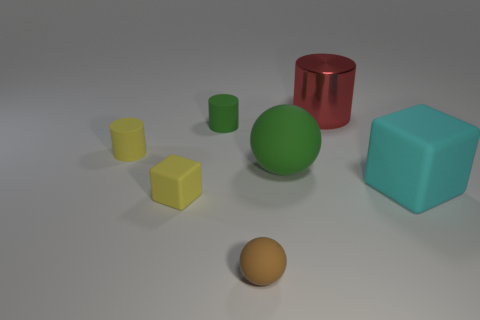Add 1 small red rubber cylinders. How many objects exist? 8 Subtract all spheres. How many objects are left? 5 Subtract all gray matte blocks. Subtract all yellow matte things. How many objects are left? 5 Add 4 rubber cylinders. How many rubber cylinders are left? 6 Add 2 large matte blocks. How many large matte blocks exist? 3 Subtract 0 brown cubes. How many objects are left? 7 